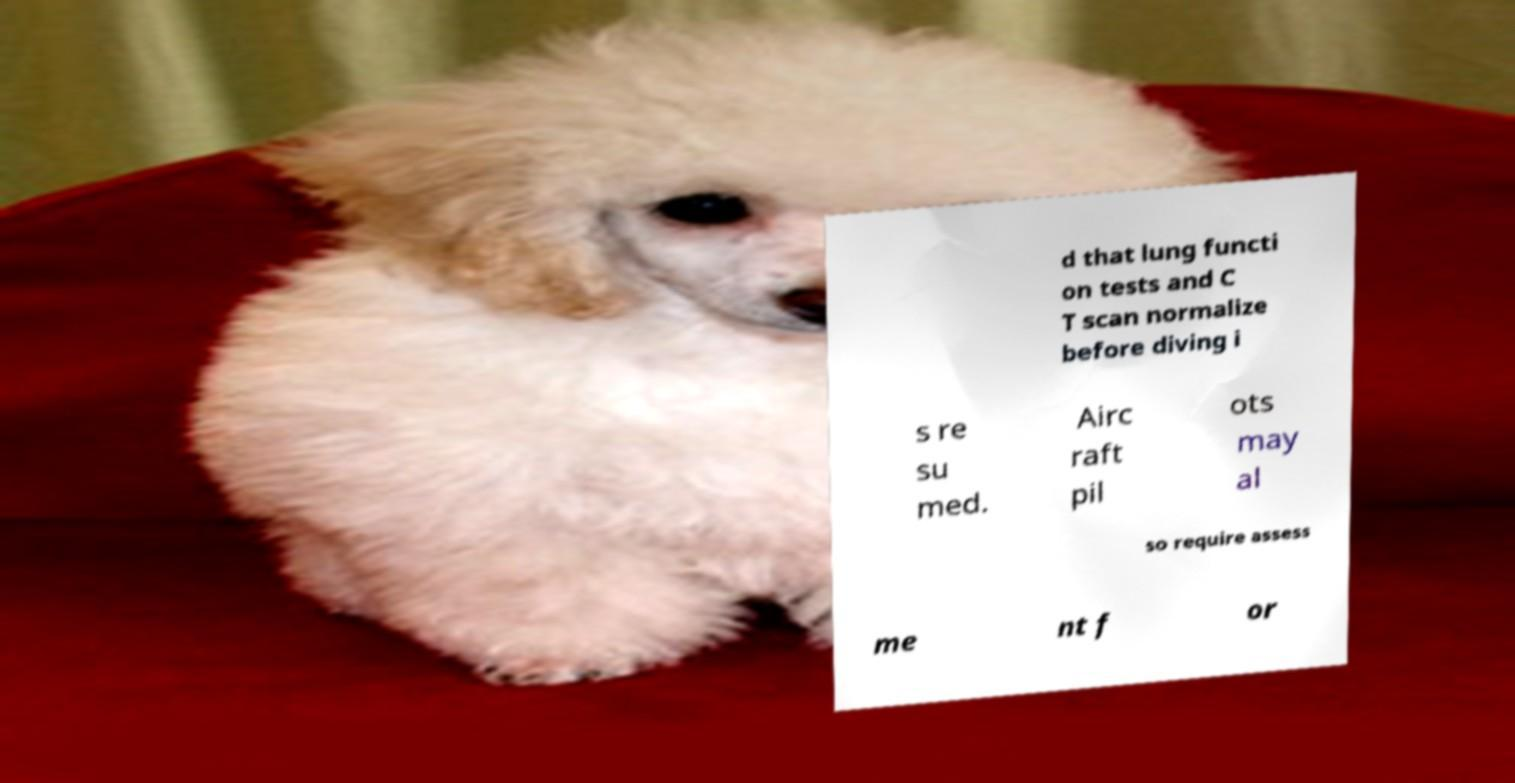Please identify and transcribe the text found in this image. d that lung functi on tests and C T scan normalize before diving i s re su med. Airc raft pil ots may al so require assess me nt f or 